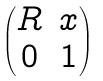Convert formula to latex. <formula><loc_0><loc_0><loc_500><loc_500>\begin{pmatrix} R & x \\ 0 & 1 \end{pmatrix}</formula> 